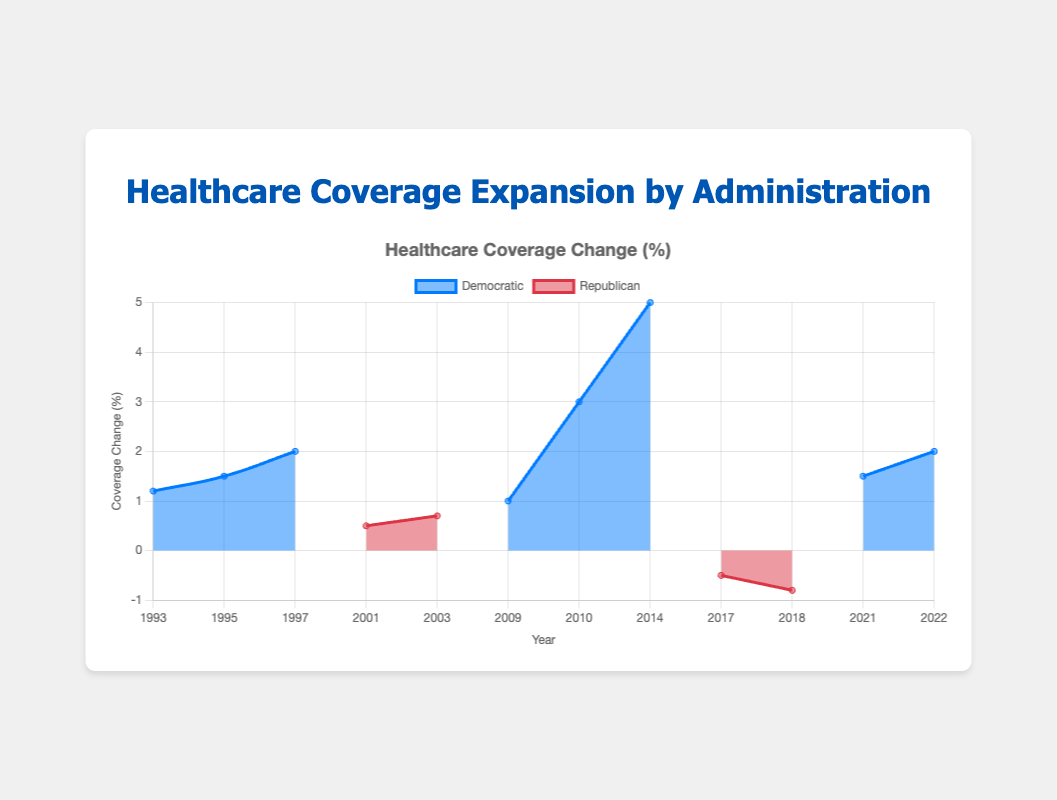Which party led administration saw the largest positive change in healthcare coverage? The Democratic administration under Obama in 2014 saw a 5.0% increase in coverage, which is the largest positive change.
Answer: Democratic What was the healthcare coverage change under the Trump administration in 2018? The chart shows a -0.8% change in healthcare coverage under the Trump administration in 2018.
Answer: -0.8% How did the healthcare coverage change under the Biden administration from 2021 to 2022? In 2021, the change was 1.5%, and in 2022, it was 2.0%. The difference is 2.0% - 1.5% = 0.5%. The healthcare coverage increased by 0.5% between 2021 and 2022.
Answer: Increased by 0.5% Which administration witnessed a decrease in healthcare coverage change and by how much? The Trump administration saw a decrease, with -0.5% in 2017 and -0.8% in 2018.
Answer: Trump, with -0.5% and -0.8% Compare the healthcare coverage change under Democratic presidents from 1993 to 2022. Which period had the most significant increase? Under Clinton, the changes were 1.2%, 1.5%, and 2.0%. Under Obama, they were 1.0%, 3.0%, and 5.0%. Under Biden, they were 1.5% and 2.0%. The most significant increase is seen under Obama in 2014 with 5.0%.
Answer: Obama administration in 2014 with 5.0% What's the average healthcare coverage change during the Obama administration? The changes in 2009, 2010, and 2014 under Obama were 1.0%, 3.0%, and 5.0%. The average is (1.0 + 3.0 + 5.0) / 3 = 3.0%.
Answer: 3.0% In which year did healthcare coverage change occur under both Democratic and Republican administrations? Coverage changes occurred in 2017 under Trump (Republican) and in 2021 under Biden (Democratic). No year saw changes from both parties simultaneously.
Answer: None 